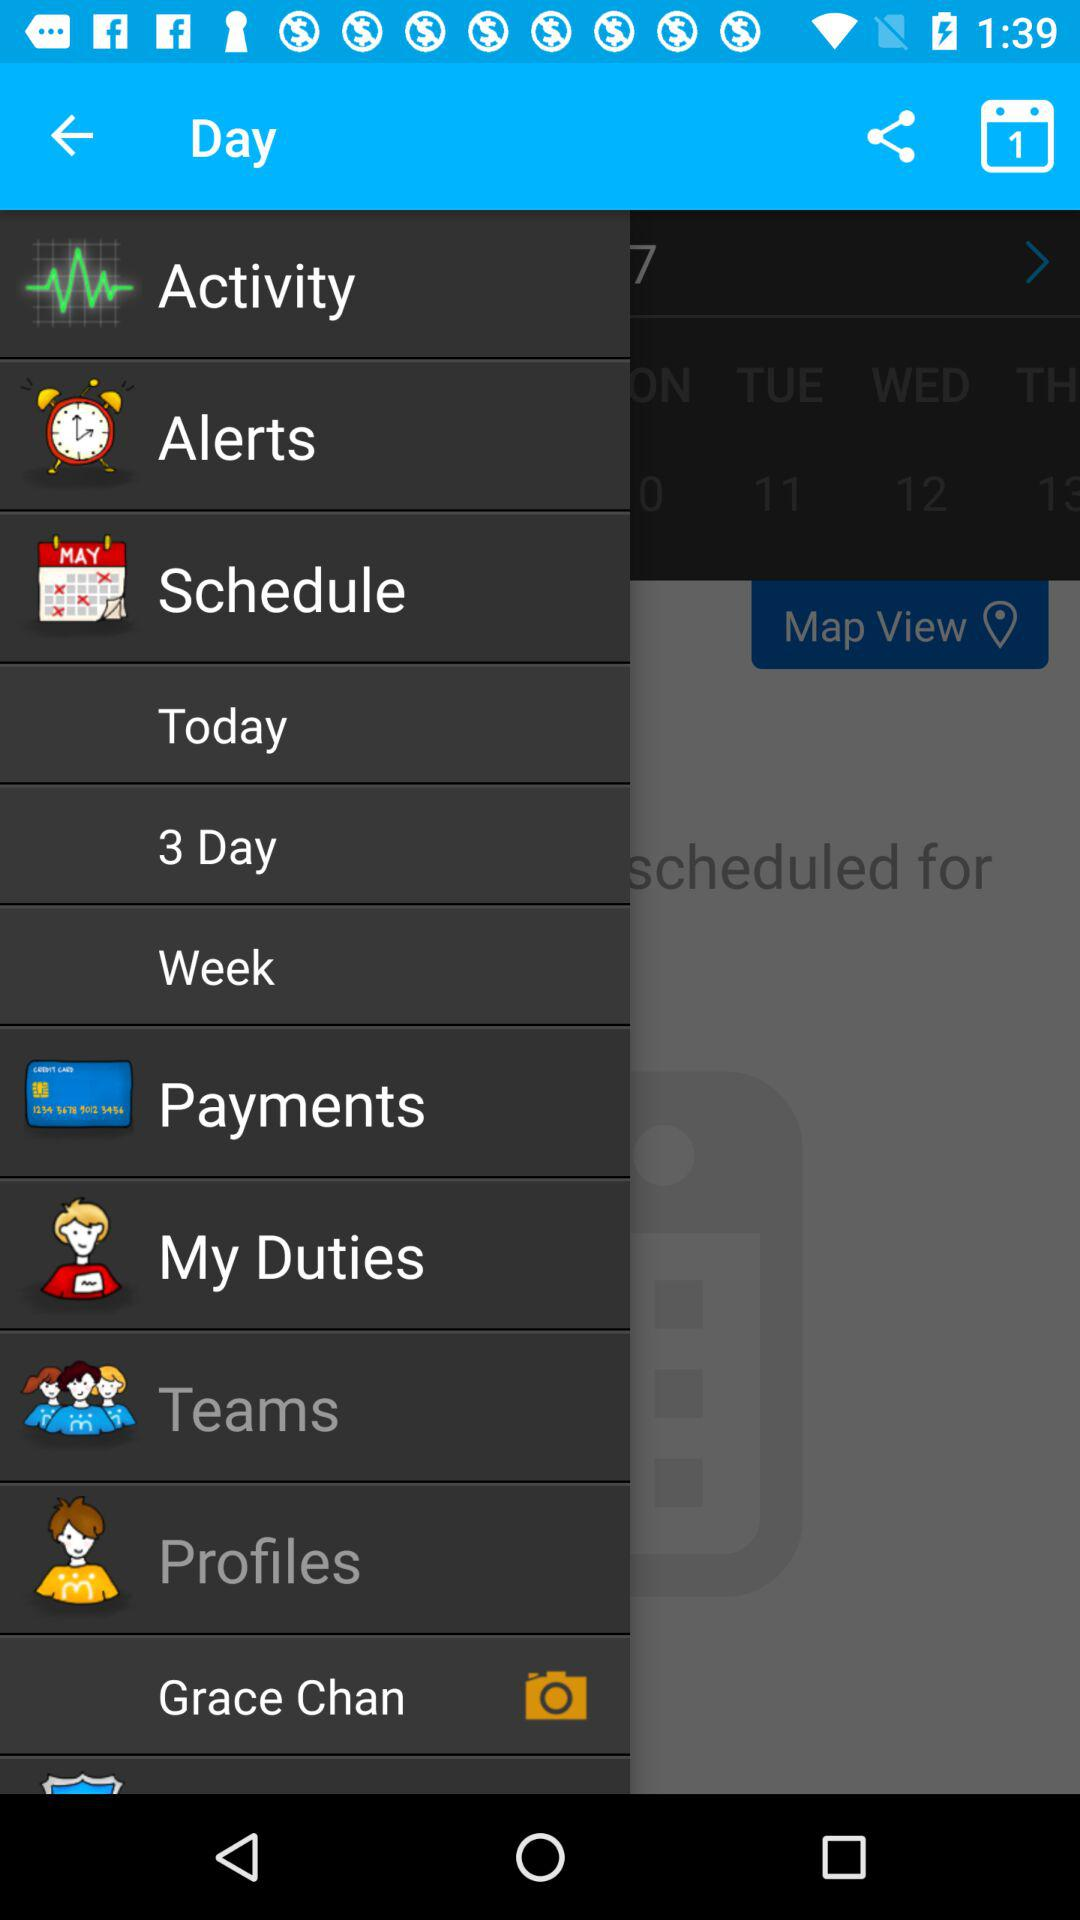What's the number of day option under Schedule?
When the provided information is insufficient, respond with <no answer>. <no answer> 